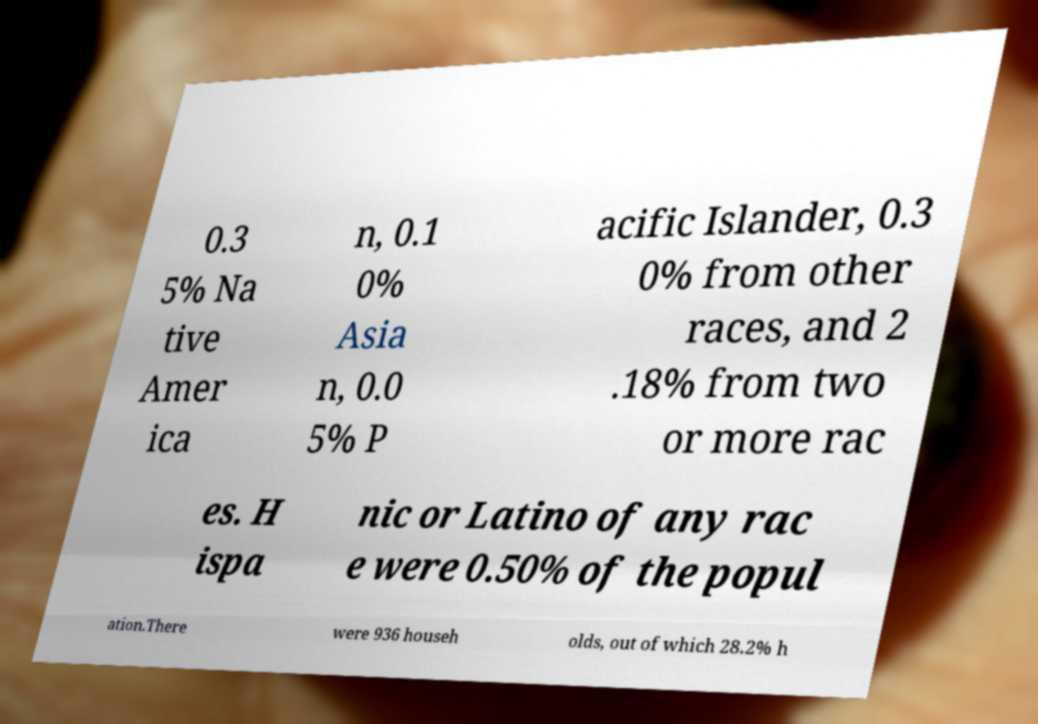Can you accurately transcribe the text from the provided image for me? 0.3 5% Na tive Amer ica n, 0.1 0% Asia n, 0.0 5% P acific Islander, 0.3 0% from other races, and 2 .18% from two or more rac es. H ispa nic or Latino of any rac e were 0.50% of the popul ation.There were 936 househ olds, out of which 28.2% h 